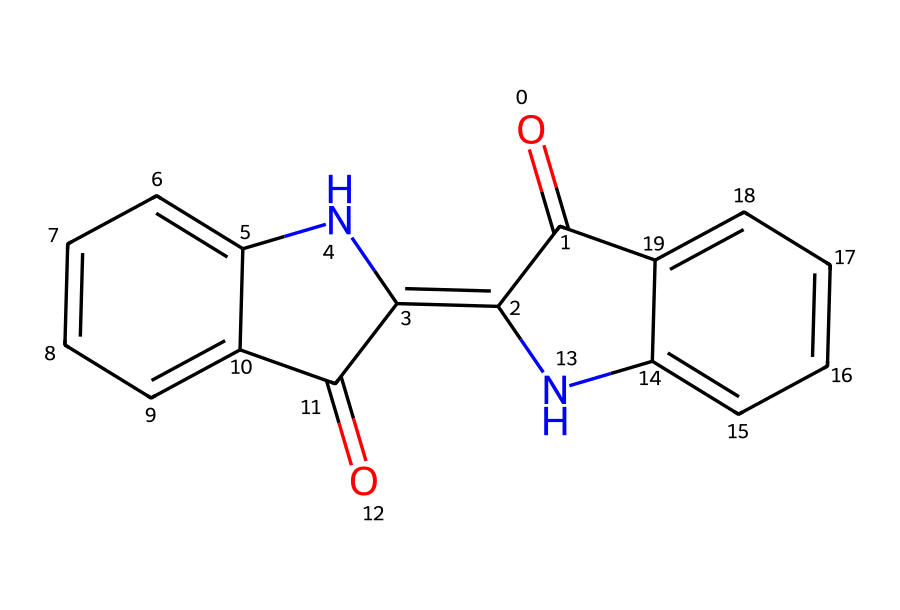What is the name of this compound? The compound represented by the given SMILES is known as indigo dye. This is identified through its well-known molecular structure, which comprises the two interconnected benzene rings with nitrogen atoms and functional groups that characterize indigo.
Answer: indigo dye How many carbon atoms are in the structure? By analyzing the SMILES representation, one can count the number of carbon atoms represented in the structure. The breakdown shows that there are 16 carbon atoms in total.
Answer: 16 What type of bonding predominates in this molecule? The molecule contains predominantly covalent bonds, as indicated by the multiple carbon to carbon and carbon to nitrogen linkages present in the structure. These bonds are formed through electron sharing, characteristic of organic compounds like indigo.
Answer: covalent Which functional groups are present in this compound? The structure of indigo contains carbonyl (C=O) and imine (C=N) functional groups. Recognition of these specific bonds allows for their identification as functional groups within the compound.
Answer: carbonyl, imine How many rings does the molecular structure have? The structure consists of three fused rings based on the arrangement of the benzene derivatives in the SMILES notation. This can be verified by visualizing the fused cycles of alternating double bonds.
Answer: 3 What is the molecular formula of indigo dye? The molecular formula can be deduced from the identified number of atoms in the compound. In this case, the molecular formula for indigo dye is C16H10N2O2, which includes its total carbon, hydrogen, nitrogen, and oxygen atoms.
Answer: C16H10N2O2 